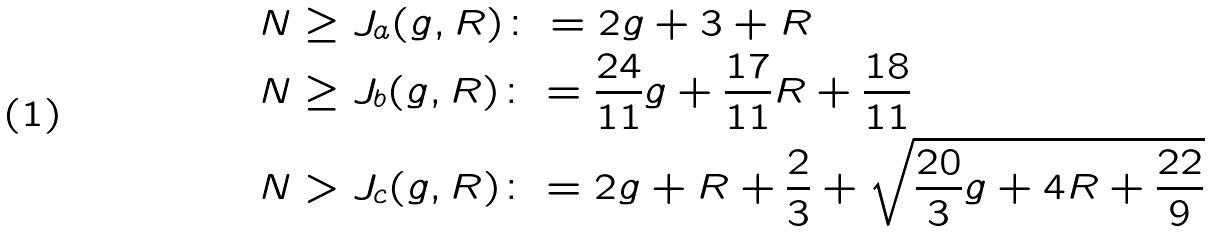Convert formula to latex. <formula><loc_0><loc_0><loc_500><loc_500>N & \geq J _ { a } ( g , R ) \colon = 2 g + 3 + R \\ N & \geq J _ { b } ( g , R ) \colon = \frac { 2 4 } { 1 1 } g + \frac { 1 7 } { 1 1 } R + \frac { 1 8 } { 1 1 } \\ N & > J _ { c } ( g , R ) \colon = 2 g + R + \frac { 2 } { 3 } + \sqrt { \frac { 2 0 } { 3 } g + 4 R + \frac { 2 2 } { 9 } }</formula> 